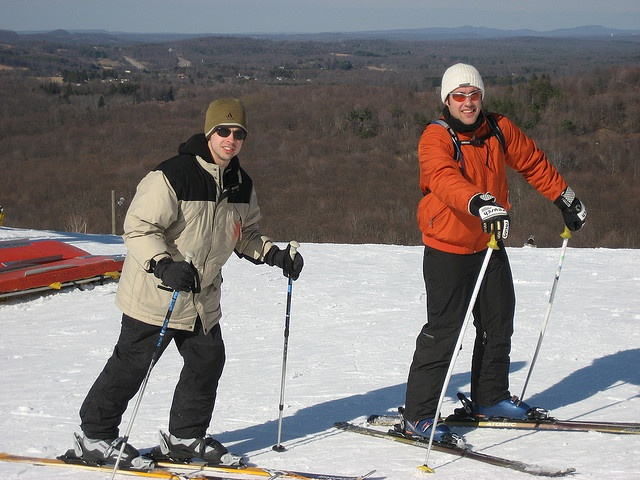Describe the objects in this image and their specific colors. I can see people in gray, black, tan, and darkgray tones, people in gray, black, red, brown, and lightgray tones, skis in gray, black, and darkgray tones, skis in gray, beige, black, and tan tones, and backpack in gray, black, darkgray, and maroon tones in this image. 